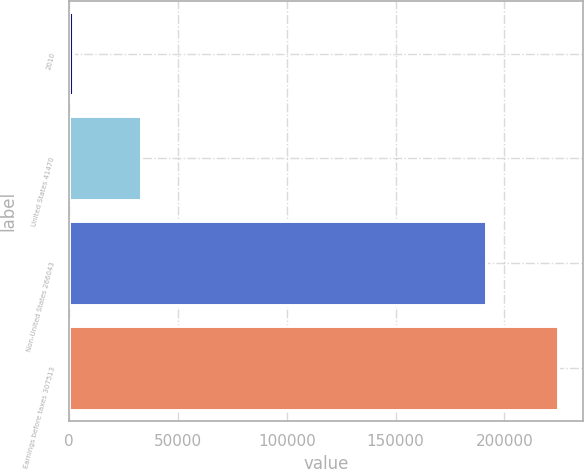<chart> <loc_0><loc_0><loc_500><loc_500><bar_chart><fcel>2010<fcel>United States 41470<fcel>Non-United States 266043<fcel>Earnings before taxes 307513<nl><fcel>2009<fcel>33263<fcel>191499<fcel>224762<nl></chart> 